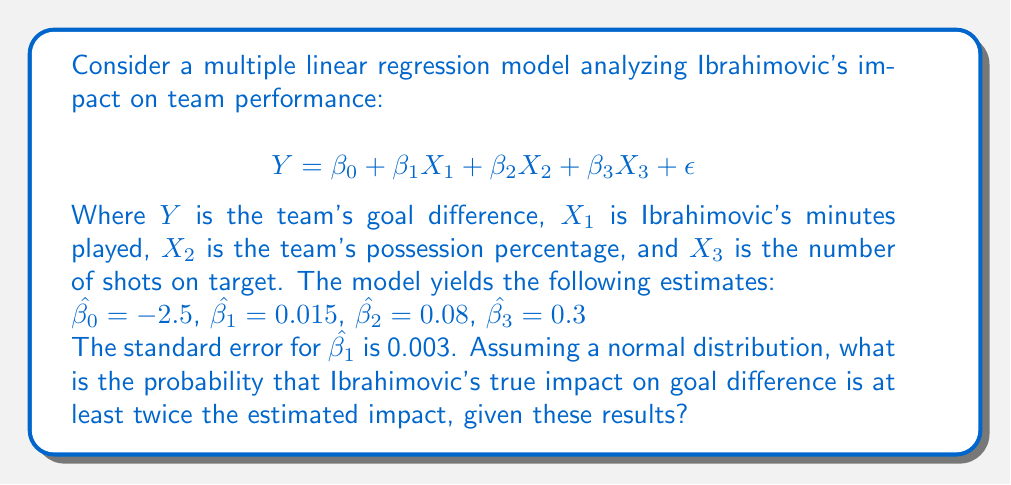Provide a solution to this math problem. To solve this problem, we'll follow these steps:

1) First, we need to understand what the question is asking. We're looking for $P(\beta_1 \geq 2\hat{\beta_1})$, where $\hat{\beta_1} = 0.015$.

2) We know that the sampling distribution of $\hat{\beta_1}$ follows a normal distribution with mean $\beta_1$ and standard error 0.003.

3) We can standardize this distribution by calculating the z-score:

   $$z = \frac{\beta_1 - \hat{\beta_1}}{SE(\hat{\beta_1})}$$

4) We want to find $P(\beta_1 \geq 2\hat{\beta_1})$, which is equivalent to:

   $$P(\beta_1 \geq 2(0.015)) = P(\beta_1 \geq 0.03)$$

5) Standardizing this:

   $$P\left(\frac{\beta_1 - 0.015}{0.003} \geq \frac{0.03 - 0.015}{0.003}\right) = P(z \geq 5)$$

6) Now we need to find the probability that a standard normal random variable is greater than or equal to 5.

7) Using a standard normal table or calculator, we find:

   $$P(z \geq 5) \approx 2.87 \times 10^{-7}$$

This extremely small probability indicates that it's very unlikely for Ibrahimovic's true impact to be at least twice the estimated impact, given these results.
Answer: $2.87 \times 10^{-7}$ 